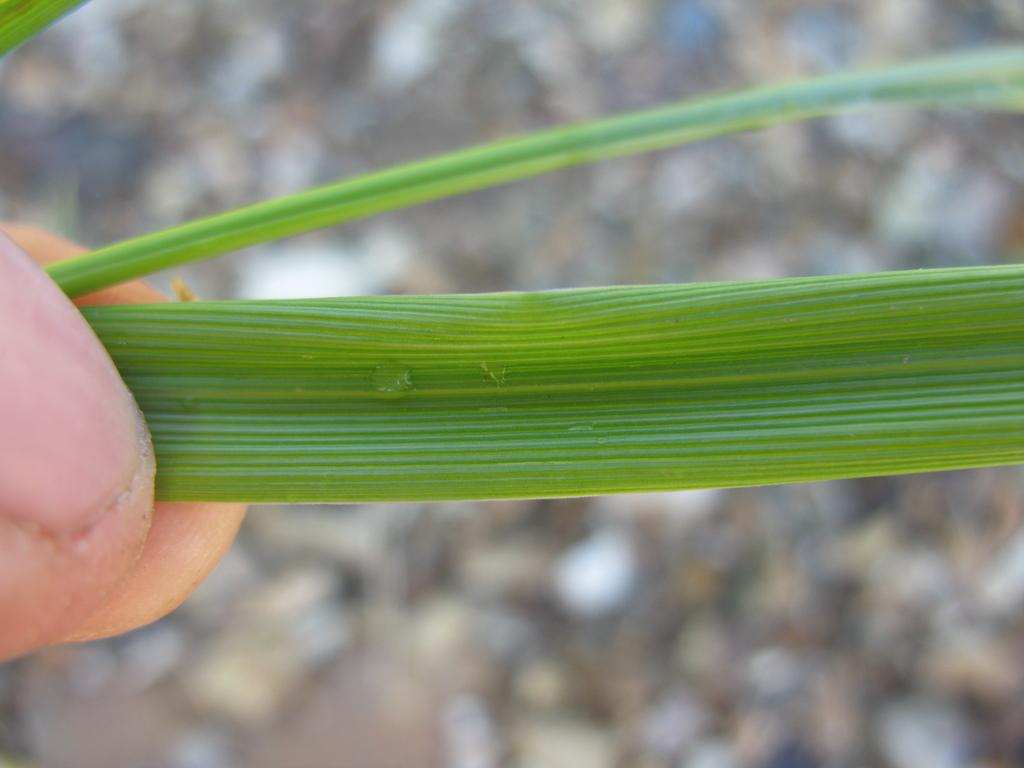What is the main subject in the foreground of the image? There is a person in the foreground of the image. What is the person holding in the image? The person is holding a plant. What type of connection can be seen between the person and the plant in the image? There is no visible connection between the person and the plant in the image; the person is simply holding the plant. 